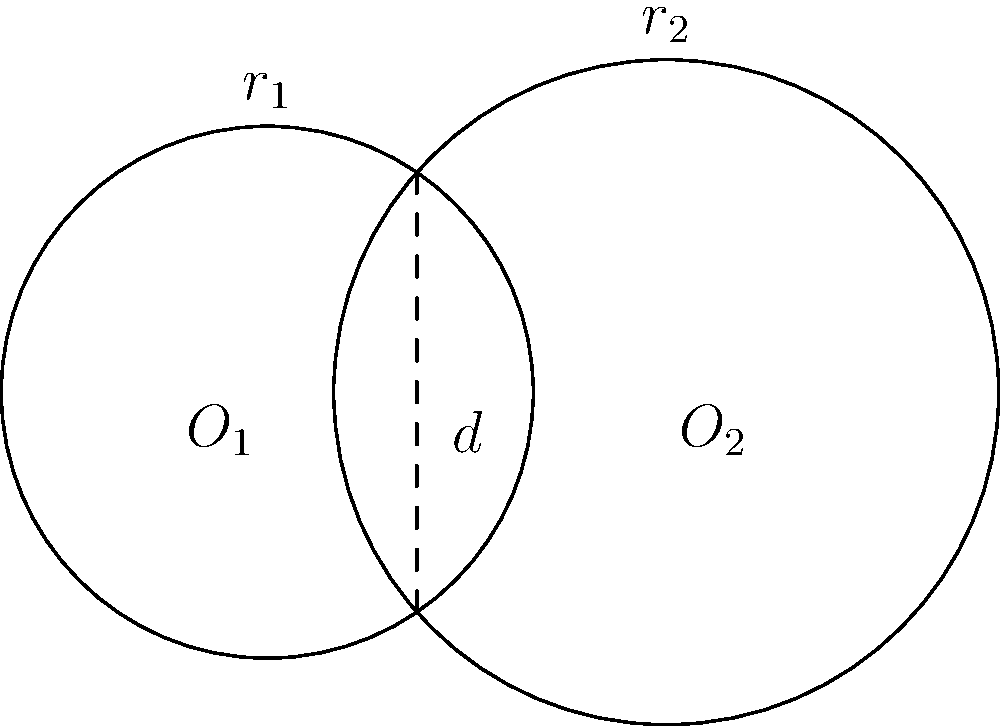In your latest historical novel about ancient Greek mathematics, you want to include a problem inspired by Archimedes' work on circle intersections. Two circles with radii $r_1 = 2$ units and $r_2 = 2.5$ units have their centers separated by a distance $d = 3$ units. What is the area of the lens-shaped region formed by their intersection? Express your answer in terms of π. To solve this problem, we'll follow these steps:

1) First, we need to find the height of the triangular part of the lens. We can do this using the Pythagorean theorem:

   Let $h$ be the height and $x$ be the distance from $O_1$ to the base of the height.
   
   $x^2 + h^2 = r_1^2$ and $(d-x)^2 + h^2 = r_2^2$

2) Subtracting these equations:

   $x^2 - (d-x)^2 = r_1^2 - r_2^2$
   $x^2 - (d^2-2dx+x^2) = r_1^2 - r_2^2$
   $2dx - d^2 = r_1^2 - r_2^2$

3) Solving for $x$:

   $x = \frac{d^2 + r_1^2 - r_2^2}{2d} = \frac{3^2 + 2^2 - 2.5^2}{2(3)} = 0.9583$ units

4) Now we can find $h$:

   $h = \sqrt{r_1^2 - x^2} = \sqrt{2^2 - 0.9583^2} = 1.7678$ units

5) The area of the lens is twice the area of the circular segment minus the area of the rhombus:

   $A_{lens} = 2(A_{segment1} + A_{segment2}) - A_{rhombus}$

6) Area of a segment: $A_{segment} = r^2 \arccos(\frac{r-h}{r}) - (r-h)\sqrt{2rh-h^2}$

   $A_{segment1} = 2^2 \arccos(\frac{2-1.7678}{2}) - (2-1.7678)\sqrt{2(2)(1.7678)-1.7678^2}$
   $= 4 \arccos(0.1161) - 0.2322\sqrt{7.0712-3.1251}$
   $= 4(1.4544) - 0.2322(2.1860) = 5.2650$ square units

   $A_{segment2} = 2.5^2 \arccos(\frac{2.5-1.7678}{2.5}) - (2.5-1.7678)\sqrt{2(2.5)(1.7678)-1.7678^2}$
   $= 6.25 \arccos(0.2929) - 0.7322\sqrt{8.839-3.1251}$
   $= 6.25(1.2793) - 0.7322(2.4845) = 6.1925$ square units

7) Area of the rhombus: $A_{rhombus} = dh = 3(1.7678) = 5.3034$ square units

8) Therefore, the area of the lens is:

   $A_{lens} = 2(5.2650 + 6.1925) - 5.3034 = 17.6116$ square units

9) To express this in terms of π, we divide by π:

   $\frac{A_{lens}}{\pi} = \frac{17.6116}{\pi} ≈ 5.6052$

Thus, the area of the lens is approximately $5.6052\pi$ square units.
Answer: $5.6052\pi$ square units 